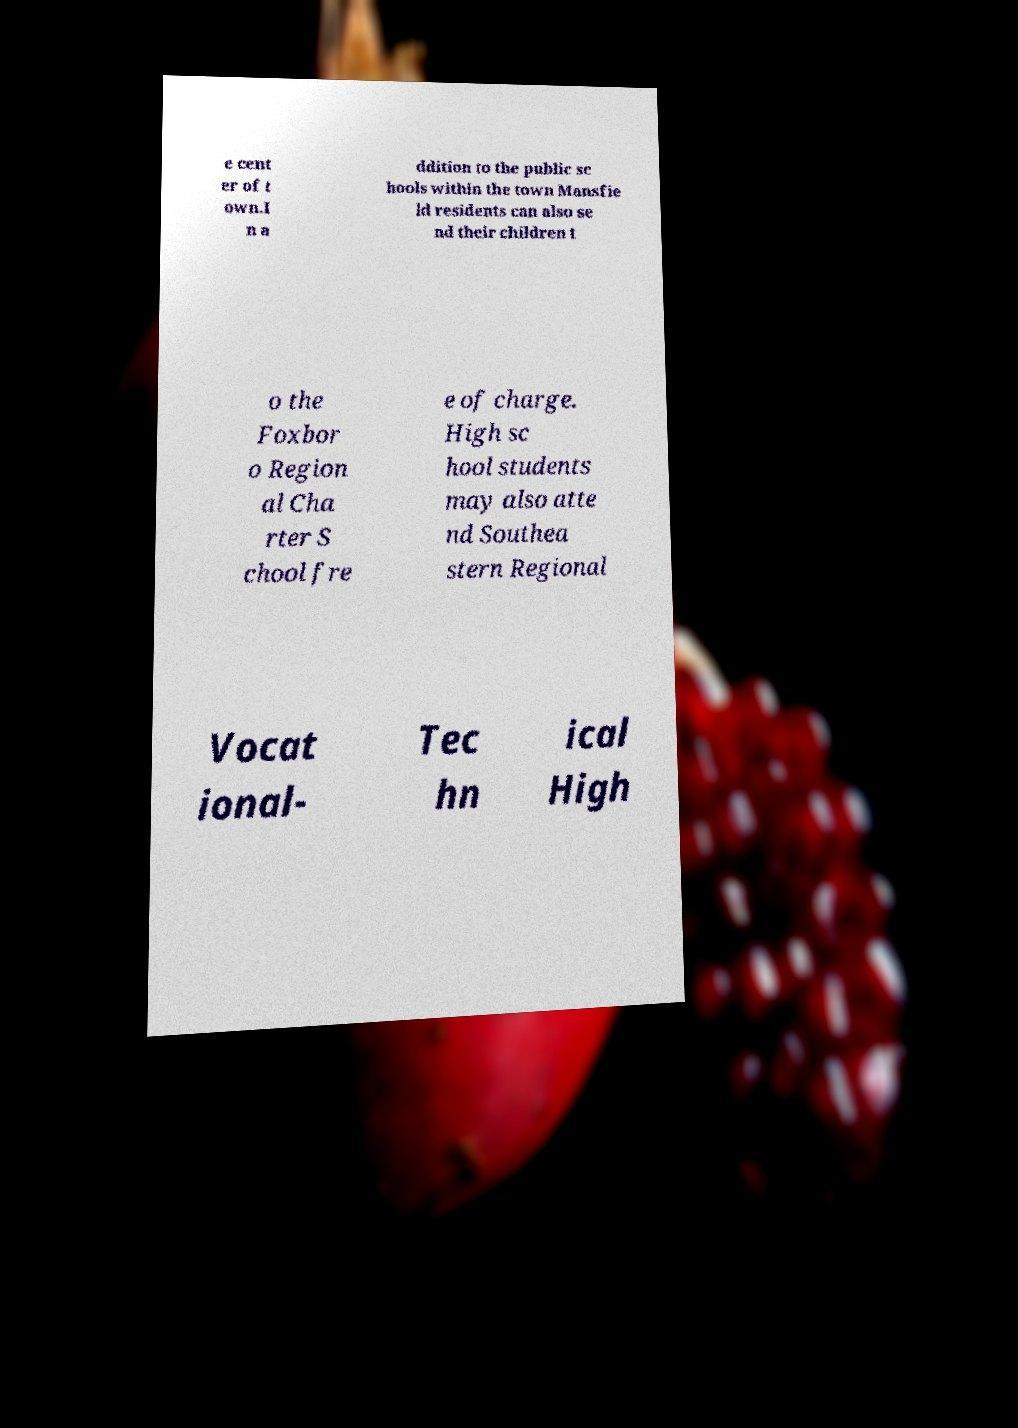Could you extract and type out the text from this image? e cent er of t own.I n a ddition to the public sc hools within the town Mansfie ld residents can also se nd their children t o the Foxbor o Region al Cha rter S chool fre e of charge. High sc hool students may also atte nd Southea stern Regional Vocat ional- Tec hn ical High 